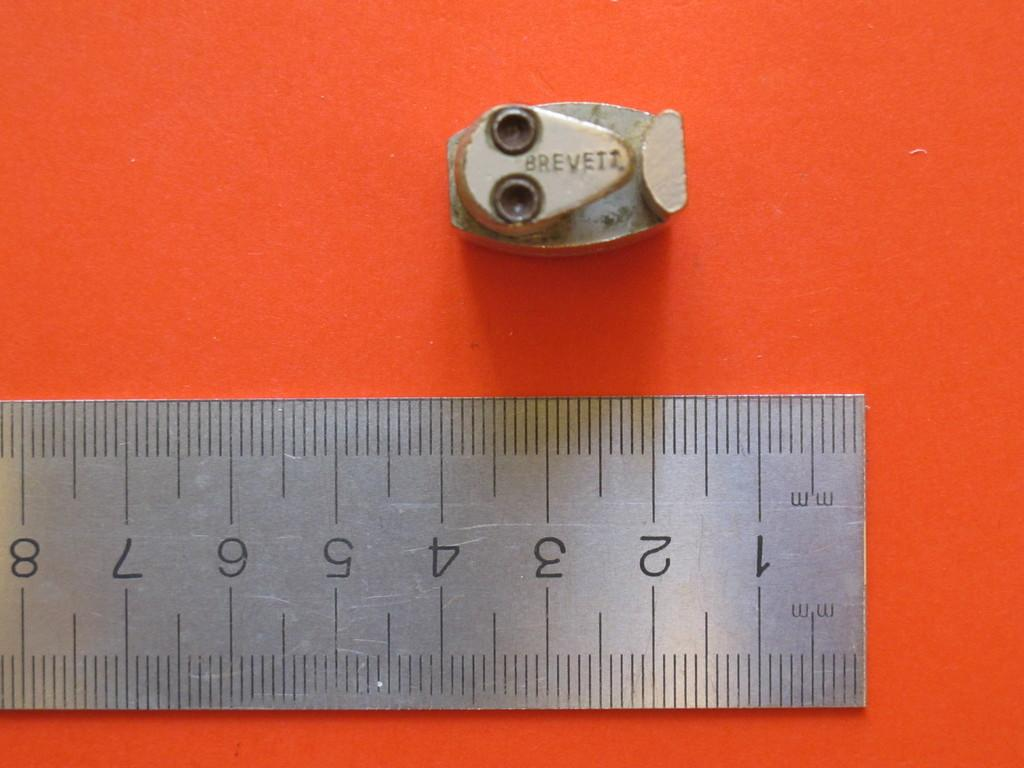<image>
Offer a succinct explanation of the picture presented. a piece of metal finding with BREVEIT ON IT and a ruler measuring mm. 